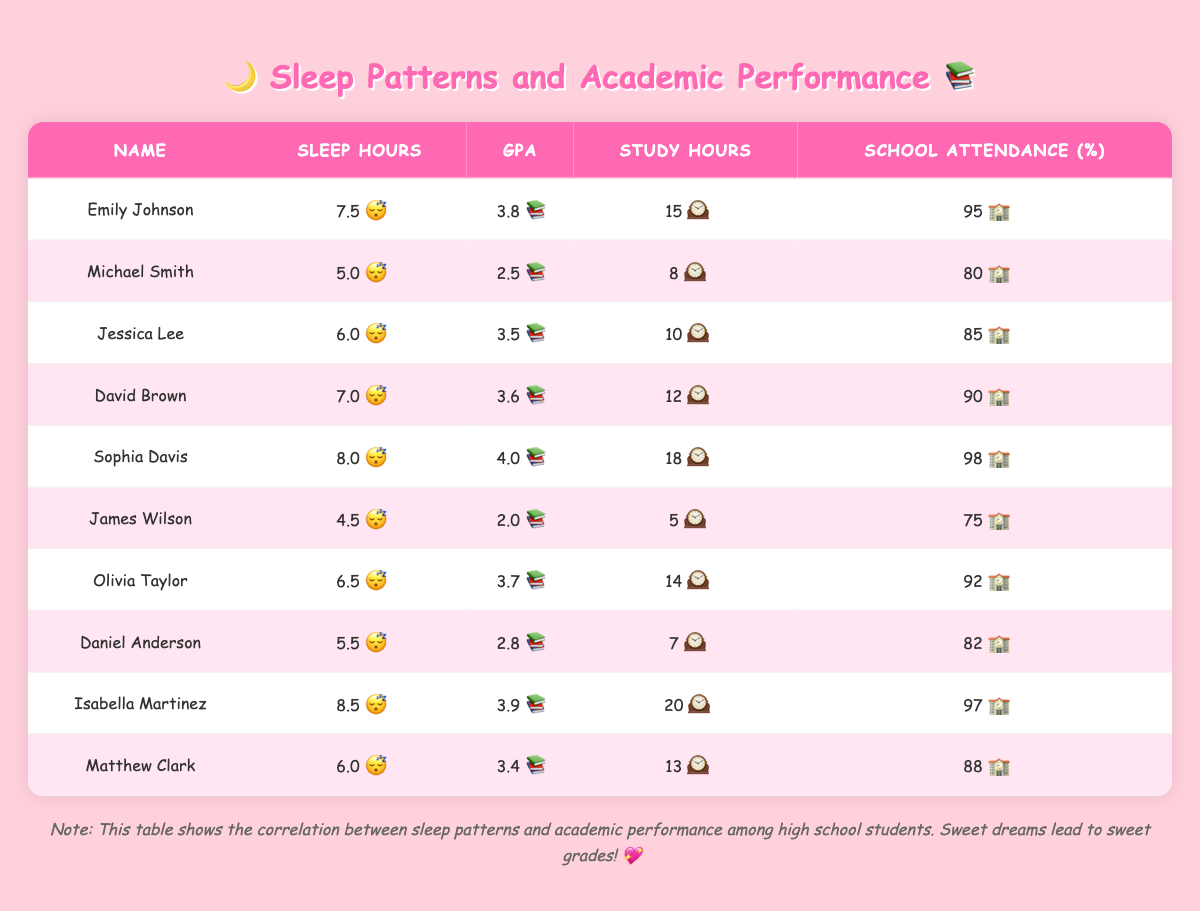What is the GPA of Sophia Davis? To find Sophia Davis's GPA, I need to look at the specific row in the table that lists her name. Upon locating her entry, the GPA is given as 4.0.
Answer: 4.0 Which student has the highest number of study hours? I will check the "Study Hours" column for the highest value by comparing all entries. The maximum value I found is 20 hours for Isabella Martinez.
Answer: Isabella Martinez What is the average sleep hours of all students? To calculate the average sleep hours, I first sum all the sleep hours (7.5 + 5.0 + 6.0 + 7.0 + 8.0 + 4.5 + 6.5 + 5.5 + 8.5 + 6.0 = 55.5). Then, I divide this sum by the number of students (10), which gives the average as 55.5 / 10 = 5.55.
Answer: 5.55 Is it true that students with higher GPAs tend to have more sleep hours? To explore this, I check the correlation between sleep hours and GPA by comparing the values in their respective columns. From the table, students like Sophia Davis and Isabella Martinez show higher GPAs with more sleep hours (8.0 and 8.5 respectively), while Michael Smith has lower GPA with less sleep (5.0). This indicates a positive trend, thus the statement is true.
Answer: True What is the difference between the highest and lowest school attendance percentages? I identify the highest school attendance percentage, which is 98% for Sophia Davis, and the lowest, which is 75% for James Wilson. The difference is then calculated as 98 - 75 = 23.
Answer: 23 Which student slept for 8 hours and had a GPA of 3.9? I will check the table for a student entry with 8 hours of sleep and find that Isabella Martinez meets both criteria (8.5 hours, GPA 3.9).
Answer: Isabella Martinez What percentage of students have a GPA of 3.5 or higher? First, I identify students with a GPA of 3.5 or higher: Emily Johnson, Jessica Lee, David Brown, Sophia Davis, Olivia Taylor, and Isabella Martinez (totaling 6 students). Then, I calculate the percentage by dividing the number of qualifying students (6) by the total number of students (10) and multiplying by 100, which gives 6/10 * 100 = 60%.
Answer: 60% Is there a student who studies for 18 hours and also has the maximum GPA? Looking at the table, I find that Sophia Davis studies for 18 hours and has a GPA of 4.0, which is the highest GPA in the table. Hence, the statement is true.
Answer: True 